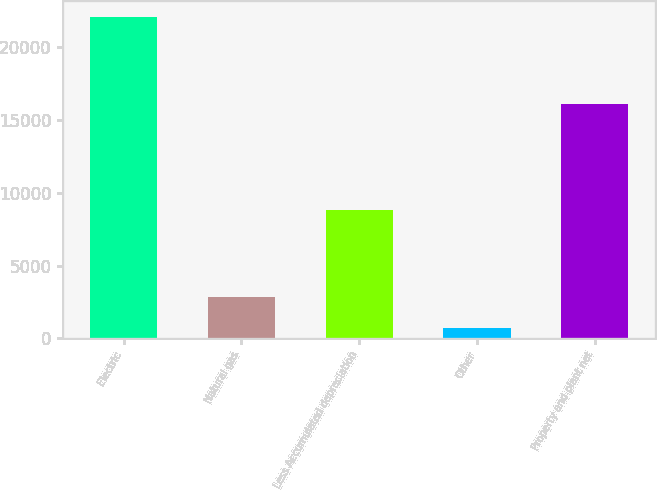Convert chart. <chart><loc_0><loc_0><loc_500><loc_500><bar_chart><fcel>Electric<fcel>Natural gas<fcel>Less Accumulated depreciation<fcel>Other<fcel>Property and plant net<nl><fcel>22055<fcel>2829.2<fcel>8823<fcel>693<fcel>16096<nl></chart> 